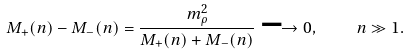Convert formula to latex. <formula><loc_0><loc_0><loc_500><loc_500>M _ { + } ( n ) - M _ { - } ( n ) = \frac { m _ { \rho } ^ { 2 } } { M _ { + } ( n ) + M _ { - } ( n ) } \longrightarrow 0 , \quad n \gg 1 .</formula> 